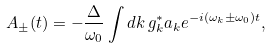Convert formula to latex. <formula><loc_0><loc_0><loc_500><loc_500>A _ { \pm } ( t ) = - \frac { \Delta } { \omega _ { 0 } } \int d k \, g ^ { * } _ { k } a _ { k } e ^ { - i ( \omega _ { k } \pm \omega _ { 0 } ) t } ,</formula> 